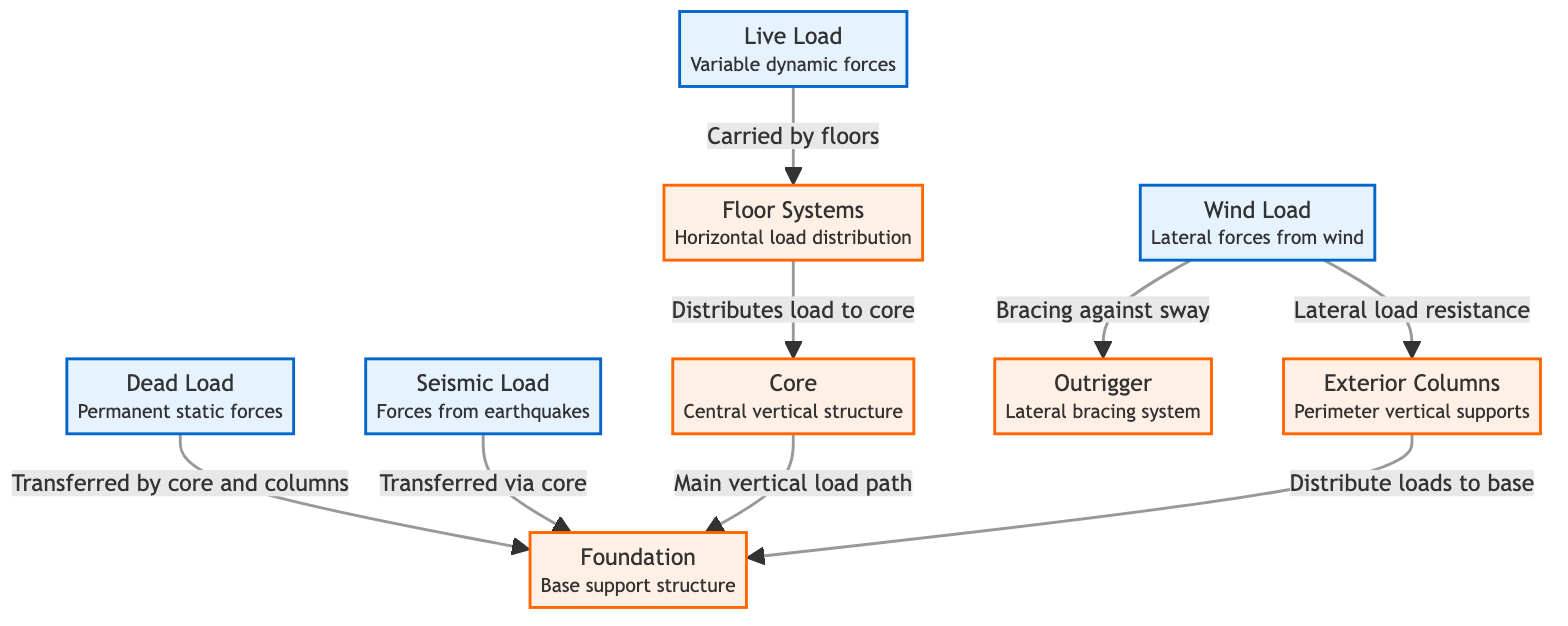What is the primary support for dead load? The diagram shows that dead load is transferred by the core and columns to the foundation. This means that the foundation serves as the main support structure for the dead load.
Answer: foundation How do wind loads affect exterior columns? The diagram indicates that wind load exerts lateral load resistance on the exterior columns. This means that the function of the exterior columns includes providing stability against wind forces.
Answer: Lateral load resistance Which structural element distributes live loads? According to the diagram, live loads are carried by the floor systems. This means that the floor systems play a key role in distributing live loads throughout the structure.
Answer: floor systems What is the relationship between core and foundation regarding seismic load? The diagram illustrates that seismic load is transferred via the core to the foundation. This shows that the core is essential for routing seismic forces down to the foundation for support.
Answer: Transferred via core How many total load types are shown in the diagram? The diagram explicitly lists four types of loads: dead load, live load, wind load, and seismic load. By counting these listed elements, we find there are four total load types depicted.
Answer: four How does the outrigger contribute to structural stability? The diagram states that the outrigger provides bracing against sway due to wind loads. This indicates that the outrigger is crucial for enhancing the lateral stability of the structure in response to wind forces.
Answer: Bracing against sway How are floor systems connected to the core? The diagram specifies that floor systems distribute loads to the core. This shows that the floor systems are integral in channeling weight to the core as part of the structural support system.
Answer: Distributes load to core Which components are part of the primary load path? The diagram reveals that the core is described as the main vertical load path leading to the foundation. This indicates that loads are primarily funneled through the core structure down to the foundation.
Answer: Core What role do exterior columns play in load distribution? The diagram shows exterior columns distribute loads to the base, meaning that they support various structural loads and help transfer those loads down to the foundation.
Answer: Distribute loads to base 